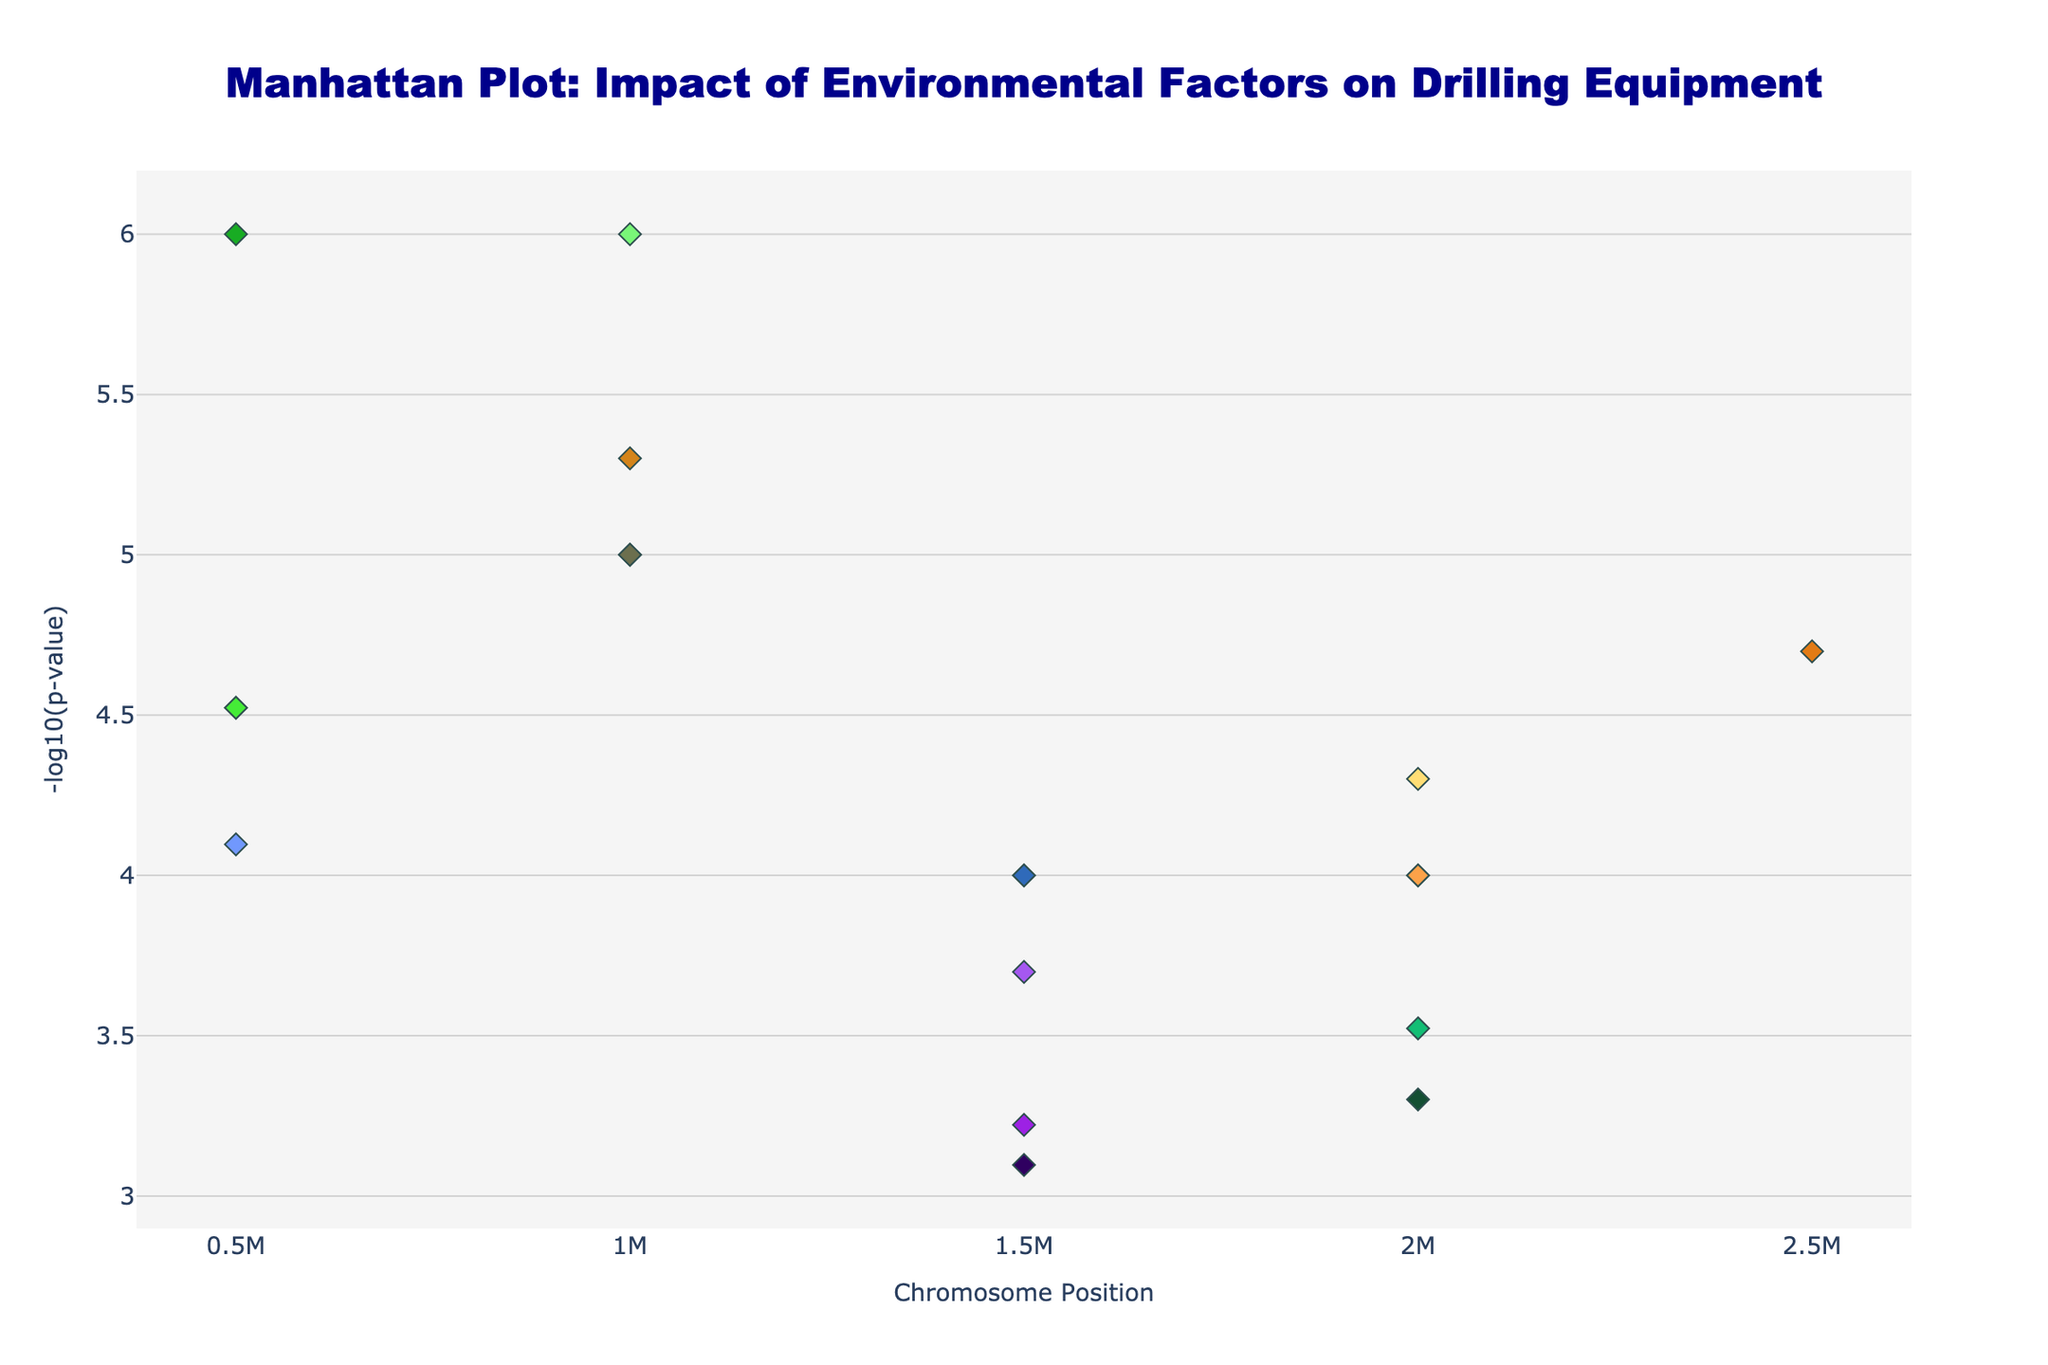What is the title of the figure? The title of the figure is usually displayed at the top and it summarizes the content and focus of the plot.
Answer: Manhattan Plot: Impact of Environmental Factors on Drilling Equipment How many chromosomes are represented in the plot? The number of chromosomes can be determined by counting the unique chromosome labels on the x-axis of the plot. The plot usually shows each chromosome with its own distinct grouping.
Answer: 8 Which chromosome has the most significant p-value indicated by the smallest p-value? The most significant p-value can be identified by the highest -log10(p-value) on the y-axis. By scanning the plot, locate the highest peak.
Answer: Chromosome 3 Which equipment type is associated with the highest peak in the plot? To find this, look for the highest peak in the plot which corresponds to the maximum -log10(p-value) and read the hover text or legend that indicates the equipment type.
Answer: Drill Pipe What environmental factor is linked to the top peak on chromosome 3? Examine the data point with the highest -log10(p-value) on chromosome 3, then refer to the hover text or labels associated with that data point to see the environmental factor.
Answer: Dust Compare the p-value significance between Mud Pump and Drill Collar. Which one is more significant and by how much? Compare the -log10(p-value) for Mud Pump and Drill Collar visible in the plot. Mud Pump appears on Chromosome 1, and Drill Collar on Chromosome 5. The more significant one will have a higher -log10(p-value). Calculate the difference in their -log10(p-value) values.
Answer: Drill Collar is more significant by 0.3010 Which location has the highest -log10(p-value) for its environmental impact on equipment performance? Locate the peak with the highest -log10(p-value) on the y-axis, then read the corresponding hover text or labels to identify the location.
Answer: New Mexico What is the total number of unique equipment types represented in the plot? Count the unique equipment types listed in the legend or from the hover text. Each equipment type has its own color in the plot.
Answer: 15 If you were to average the -log10(p-values) of the top peaks in Wyoming and California, what would it be? Identify the -log10(p-values) for the top peaks in Wyoming and California from the plot, then calculate the average of these two values.
Answer: (4.69897 + 4.52287)/2 = 4.61092 Which equipment has a higher p-value, Shale Shaker or Mud Motor? To determine this, compare the -log10(p-values) of Shale Shaker and Mud Motor. The lower -log10(p-value) indicates a higher actual p-value.
Answer: Mud Motor 